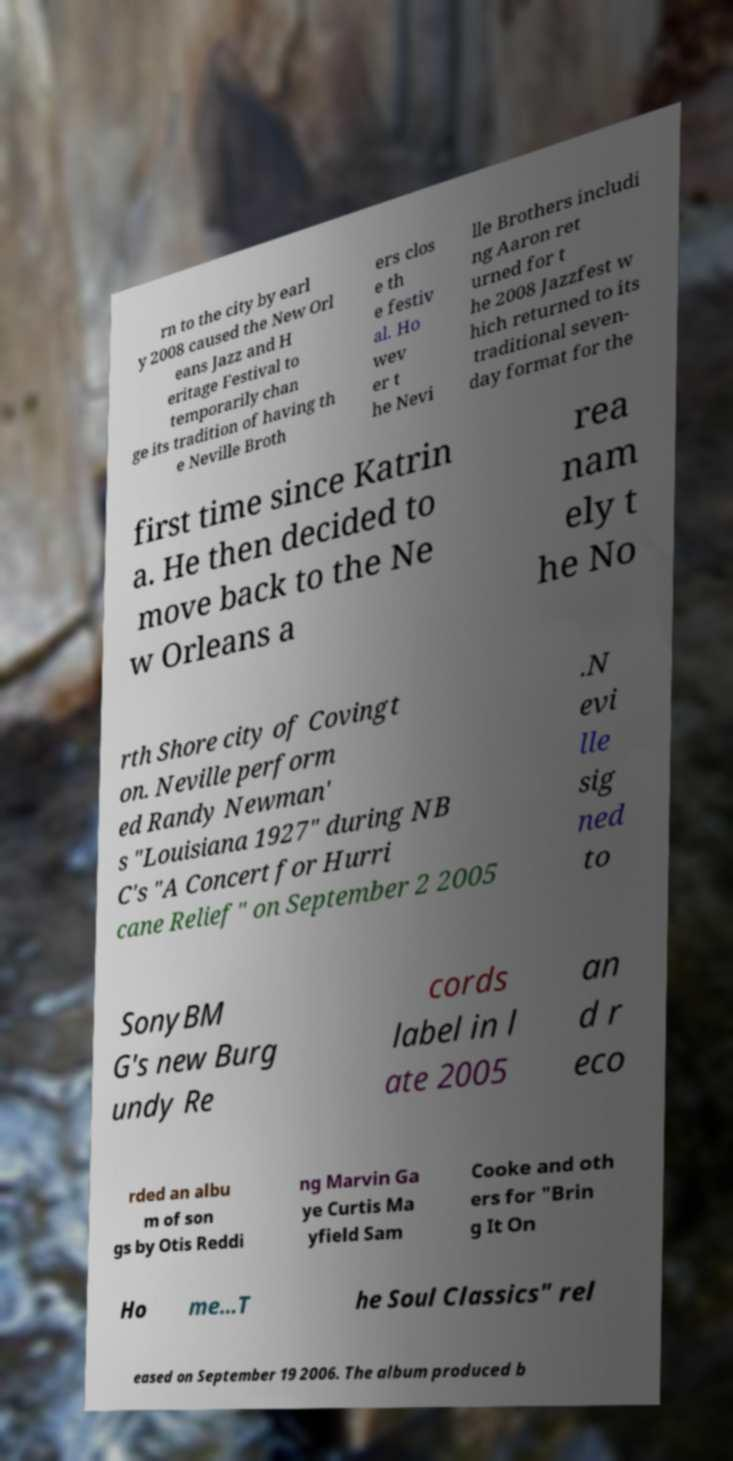There's text embedded in this image that I need extracted. Can you transcribe it verbatim? rn to the city by earl y 2008 caused the New Orl eans Jazz and H eritage Festival to temporarily chan ge its tradition of having th e Neville Broth ers clos e th e festiv al. Ho wev er t he Nevi lle Brothers includi ng Aaron ret urned for t he 2008 Jazzfest w hich returned to its traditional seven- day format for the first time since Katrin a. He then decided to move back to the Ne w Orleans a rea nam ely t he No rth Shore city of Covingt on. Neville perform ed Randy Newman' s "Louisiana 1927" during NB C's "A Concert for Hurri cane Relief" on September 2 2005 .N evi lle sig ned to SonyBM G's new Burg undy Re cords label in l ate 2005 an d r eco rded an albu m of son gs by Otis Reddi ng Marvin Ga ye Curtis Ma yfield Sam Cooke and oth ers for "Brin g It On Ho me...T he Soul Classics" rel eased on September 19 2006. The album produced b 